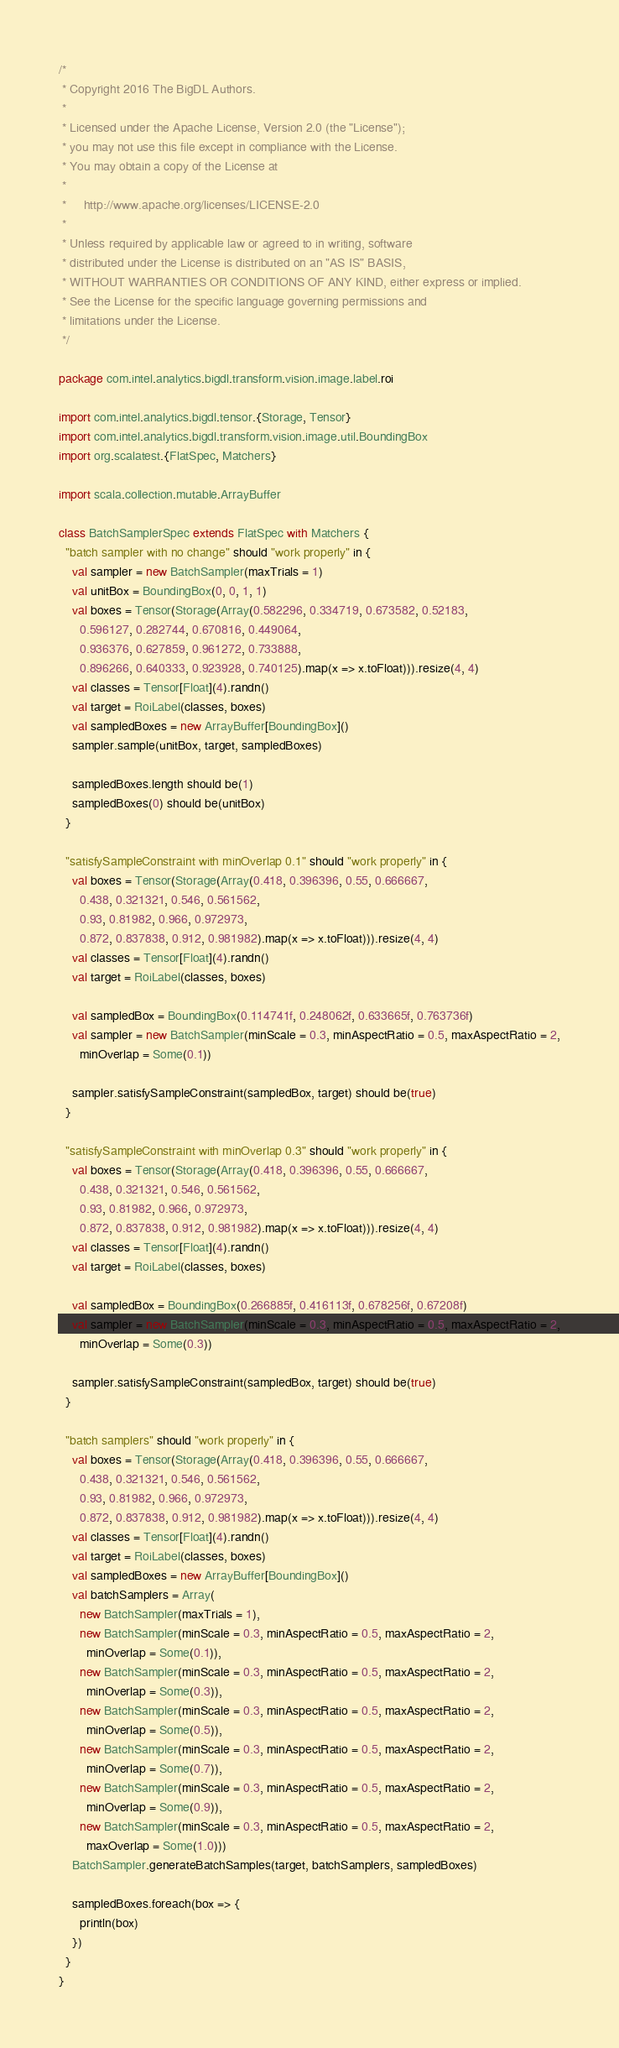<code> <loc_0><loc_0><loc_500><loc_500><_Scala_>/*
 * Copyright 2016 The BigDL Authors.
 *
 * Licensed under the Apache License, Version 2.0 (the "License");
 * you may not use this file except in compliance with the License.
 * You may obtain a copy of the License at
 *
 *     http://www.apache.org/licenses/LICENSE-2.0
 *
 * Unless required by applicable law or agreed to in writing, software
 * distributed under the License is distributed on an "AS IS" BASIS,
 * WITHOUT WARRANTIES OR CONDITIONS OF ANY KIND, either express or implied.
 * See the License for the specific language governing permissions and
 * limitations under the License.
 */

package com.intel.analytics.bigdl.transform.vision.image.label.roi

import com.intel.analytics.bigdl.tensor.{Storage, Tensor}
import com.intel.analytics.bigdl.transform.vision.image.util.BoundingBox
import org.scalatest.{FlatSpec, Matchers}

import scala.collection.mutable.ArrayBuffer

class BatchSamplerSpec extends FlatSpec with Matchers {
  "batch sampler with no change" should "work properly" in {
    val sampler = new BatchSampler(maxTrials = 1)
    val unitBox = BoundingBox(0, 0, 1, 1)
    val boxes = Tensor(Storage(Array(0.582296, 0.334719, 0.673582, 0.52183,
      0.596127, 0.282744, 0.670816, 0.449064,
      0.936376, 0.627859, 0.961272, 0.733888,
      0.896266, 0.640333, 0.923928, 0.740125).map(x => x.toFloat))).resize(4, 4)
    val classes = Tensor[Float](4).randn()
    val target = RoiLabel(classes, boxes)
    val sampledBoxes = new ArrayBuffer[BoundingBox]()
    sampler.sample(unitBox, target, sampledBoxes)

    sampledBoxes.length should be(1)
    sampledBoxes(0) should be(unitBox)
  }

  "satisfySampleConstraint with minOverlap 0.1" should "work properly" in {
    val boxes = Tensor(Storage(Array(0.418, 0.396396, 0.55, 0.666667,
      0.438, 0.321321, 0.546, 0.561562,
      0.93, 0.81982, 0.966, 0.972973,
      0.872, 0.837838, 0.912, 0.981982).map(x => x.toFloat))).resize(4, 4)
    val classes = Tensor[Float](4).randn()
    val target = RoiLabel(classes, boxes)

    val sampledBox = BoundingBox(0.114741f, 0.248062f, 0.633665f, 0.763736f)
    val sampler = new BatchSampler(minScale = 0.3, minAspectRatio = 0.5, maxAspectRatio = 2,
      minOverlap = Some(0.1))

    sampler.satisfySampleConstraint(sampledBox, target) should be(true)
  }

  "satisfySampleConstraint with minOverlap 0.3" should "work properly" in {
    val boxes = Tensor(Storage(Array(0.418, 0.396396, 0.55, 0.666667,
      0.438, 0.321321, 0.546, 0.561562,
      0.93, 0.81982, 0.966, 0.972973,
      0.872, 0.837838, 0.912, 0.981982).map(x => x.toFloat))).resize(4, 4)
    val classes = Tensor[Float](4).randn()
    val target = RoiLabel(classes, boxes)

    val sampledBox = BoundingBox(0.266885f, 0.416113f, 0.678256f, 0.67208f)
    val sampler = new BatchSampler(minScale = 0.3, minAspectRatio = 0.5, maxAspectRatio = 2,
      minOverlap = Some(0.3))

    sampler.satisfySampleConstraint(sampledBox, target) should be(true)
  }

  "batch samplers" should "work properly" in {
    val boxes = Tensor(Storage(Array(0.418, 0.396396, 0.55, 0.666667,
      0.438, 0.321321, 0.546, 0.561562,
      0.93, 0.81982, 0.966, 0.972973,
      0.872, 0.837838, 0.912, 0.981982).map(x => x.toFloat))).resize(4, 4)
    val classes = Tensor[Float](4).randn()
    val target = RoiLabel(classes, boxes)
    val sampledBoxes = new ArrayBuffer[BoundingBox]()
    val batchSamplers = Array(
      new BatchSampler(maxTrials = 1),
      new BatchSampler(minScale = 0.3, minAspectRatio = 0.5, maxAspectRatio = 2,
        minOverlap = Some(0.1)),
      new BatchSampler(minScale = 0.3, minAspectRatio = 0.5, maxAspectRatio = 2,
        minOverlap = Some(0.3)),
      new BatchSampler(minScale = 0.3, minAspectRatio = 0.5, maxAspectRatio = 2,
        minOverlap = Some(0.5)),
      new BatchSampler(minScale = 0.3, minAspectRatio = 0.5, maxAspectRatio = 2,
        minOverlap = Some(0.7)),
      new BatchSampler(minScale = 0.3, minAspectRatio = 0.5, maxAspectRatio = 2,
        minOverlap = Some(0.9)),
      new BatchSampler(minScale = 0.3, minAspectRatio = 0.5, maxAspectRatio = 2,
        maxOverlap = Some(1.0)))
    BatchSampler.generateBatchSamples(target, batchSamplers, sampledBoxes)

    sampledBoxes.foreach(box => {
      println(box)
    })
  }
}
</code> 